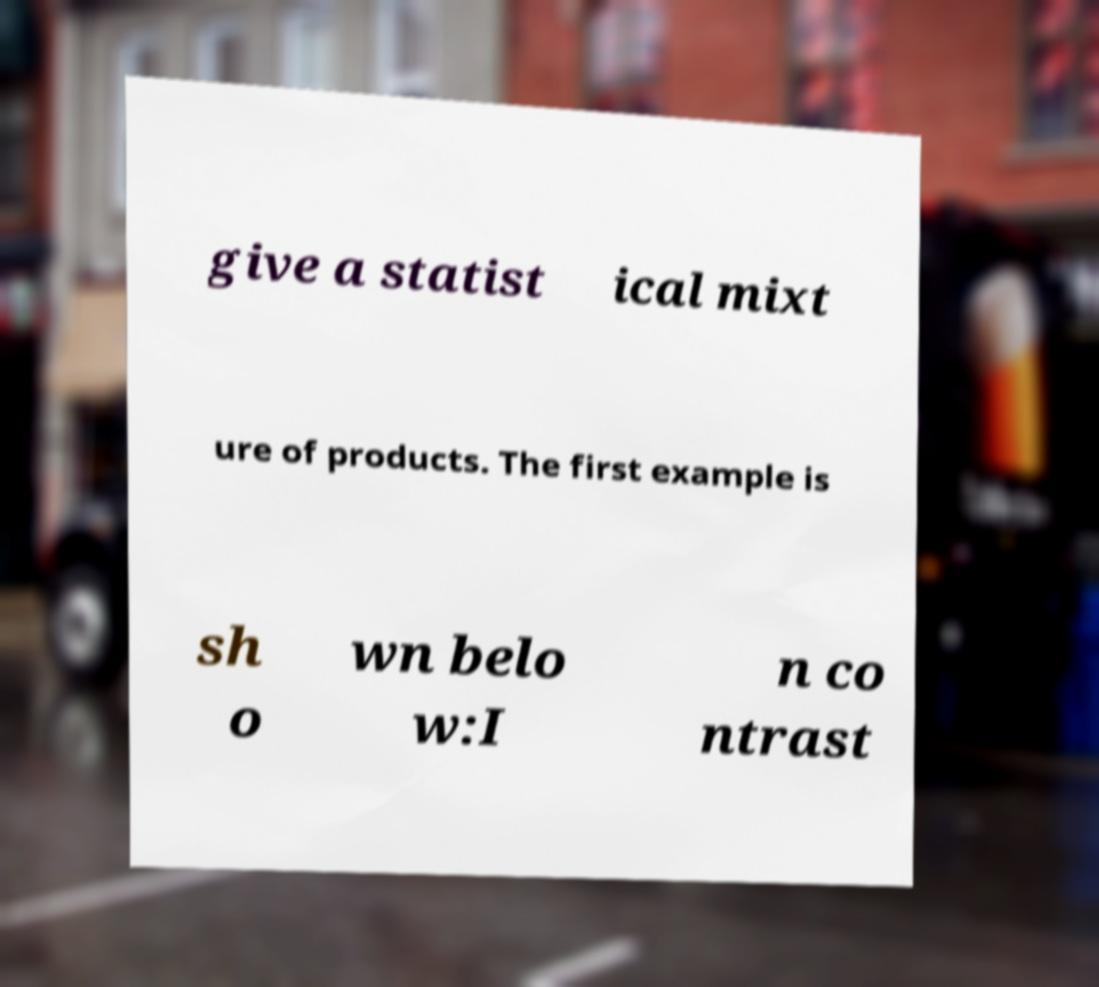Can you accurately transcribe the text from the provided image for me? give a statist ical mixt ure of products. The first example is sh o wn belo w:I n co ntrast 